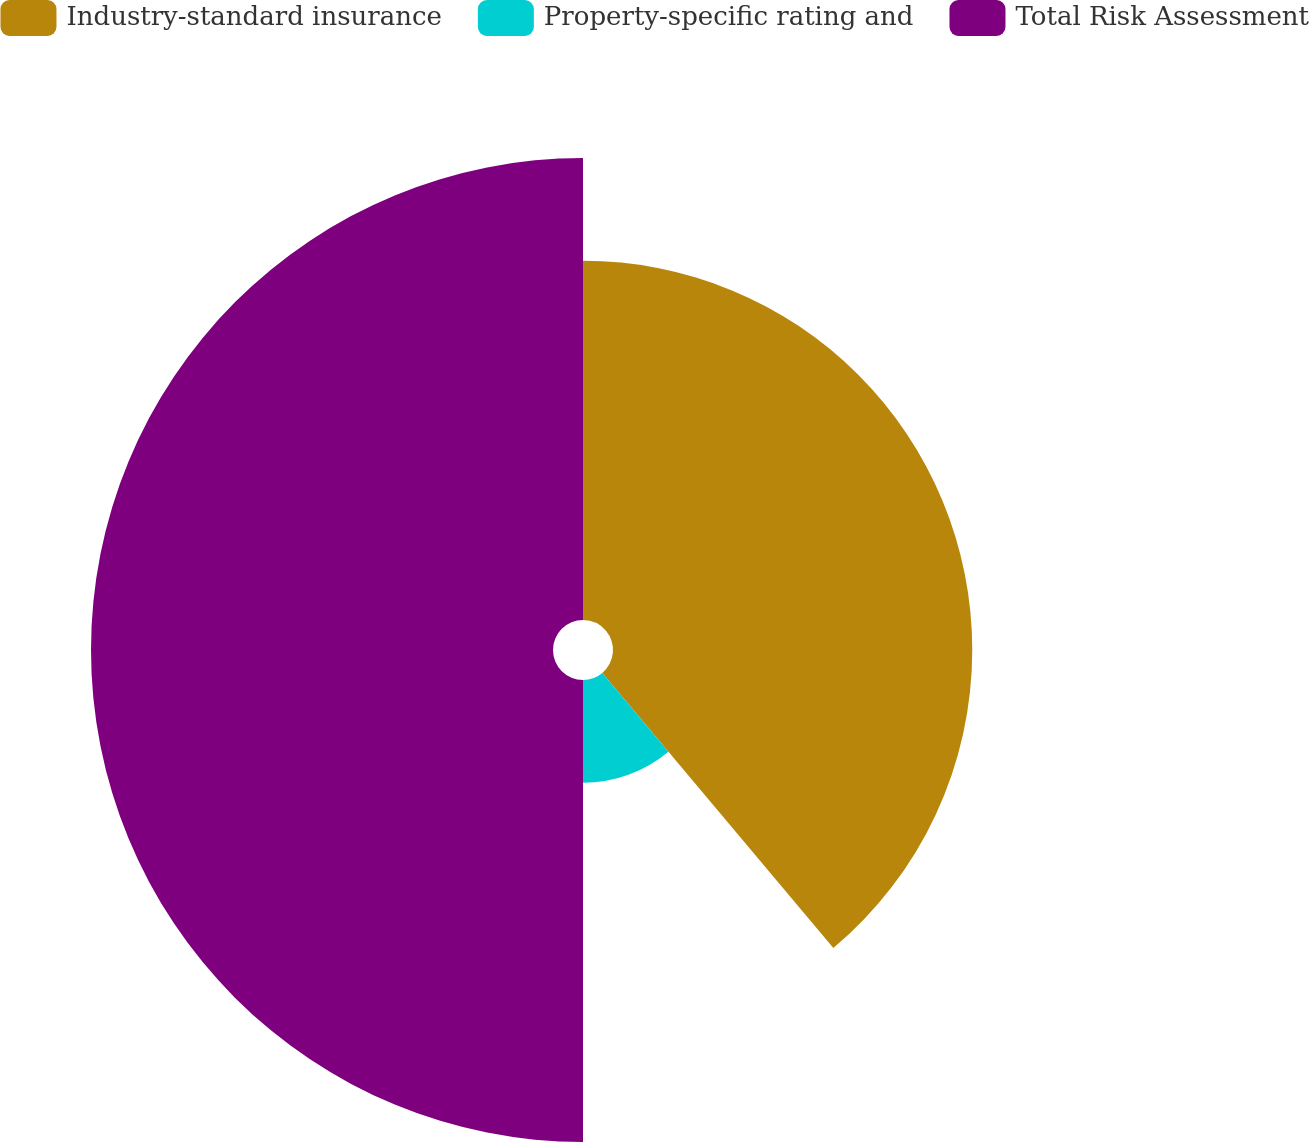<chart> <loc_0><loc_0><loc_500><loc_500><pie_chart><fcel>Industry-standard insurance<fcel>Property-specific rating and<fcel>Total Risk Assessment<nl><fcel>38.88%<fcel>11.12%<fcel>50.0%<nl></chart> 